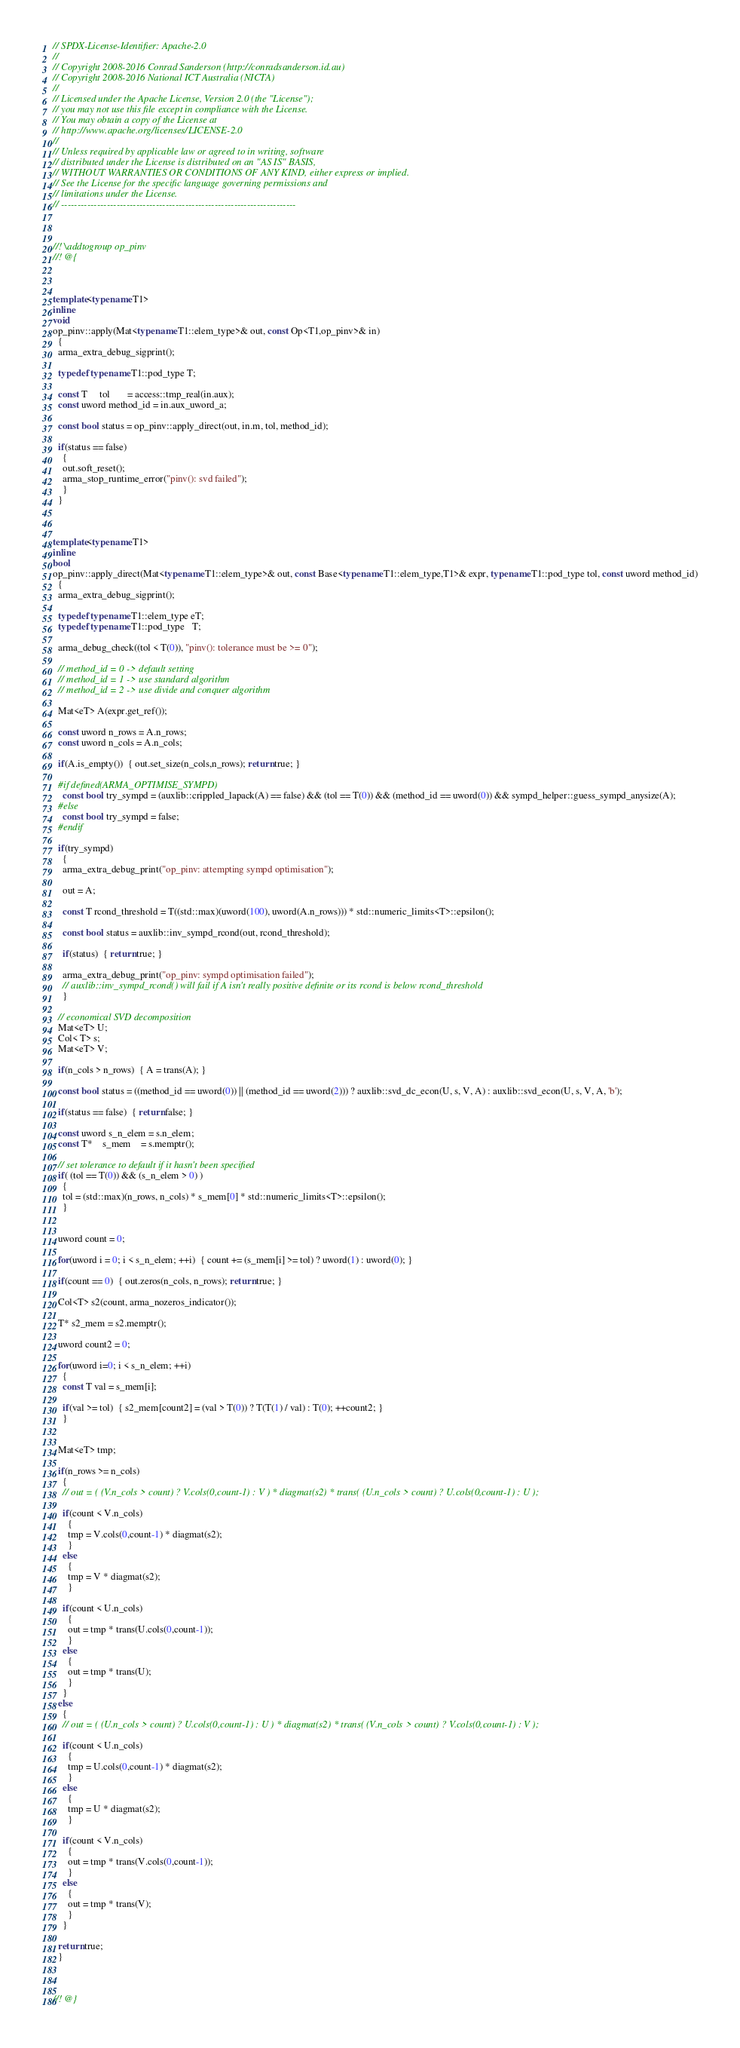<code> <loc_0><loc_0><loc_500><loc_500><_C++_>// SPDX-License-Identifier: Apache-2.0
// 
// Copyright 2008-2016 Conrad Sanderson (http://conradsanderson.id.au)
// Copyright 2008-2016 National ICT Australia (NICTA)
// 
// Licensed under the Apache License, Version 2.0 (the "License");
// you may not use this file except in compliance with the License.
// You may obtain a copy of the License at
// http://www.apache.org/licenses/LICENSE-2.0
// 
// Unless required by applicable law or agreed to in writing, software
// distributed under the License is distributed on an "AS IS" BASIS,
// WITHOUT WARRANTIES OR CONDITIONS OF ANY KIND, either express or implied.
// See the License for the specific language governing permissions and
// limitations under the License.
// ------------------------------------------------------------------------



//! \addtogroup op_pinv
//! @{



template<typename T1>
inline
void
op_pinv::apply(Mat<typename T1::elem_type>& out, const Op<T1,op_pinv>& in)
  {
  arma_extra_debug_sigprint();
  
  typedef typename T1::pod_type T;
  
  const T     tol       = access::tmp_real(in.aux);
  const uword method_id = in.aux_uword_a;
  
  const bool status = op_pinv::apply_direct(out, in.m, tol, method_id);
  
  if(status == false)
    {
    out.soft_reset();
    arma_stop_runtime_error("pinv(): svd failed");
    }
  }



template<typename T1>
inline
bool
op_pinv::apply_direct(Mat<typename T1::elem_type>& out, const Base<typename T1::elem_type,T1>& expr, typename T1::pod_type tol, const uword method_id)
  {
  arma_extra_debug_sigprint();
  
  typedef typename T1::elem_type eT;
  typedef typename T1::pod_type   T;
  
  arma_debug_check((tol < T(0)), "pinv(): tolerance must be >= 0");
  
  // method_id = 0 -> default setting
  // method_id = 1 -> use standard algorithm
  // method_id = 2 -> use divide and conquer algorithm
  
  Mat<eT> A(expr.get_ref());
  
  const uword n_rows = A.n_rows;
  const uword n_cols = A.n_cols;
  
  if(A.is_empty())  { out.set_size(n_cols,n_rows); return true; }
  
  #if defined(ARMA_OPTIMISE_SYMPD)
    const bool try_sympd = (auxlib::crippled_lapack(A) == false) && (tol == T(0)) && (method_id == uword(0)) && sympd_helper::guess_sympd_anysize(A);
  #else
    const bool try_sympd = false;
  #endif
  
  if(try_sympd)
    {
    arma_extra_debug_print("op_pinv: attempting sympd optimisation");
    
    out = A;
    
    const T rcond_threshold = T((std::max)(uword(100), uword(A.n_rows))) * std::numeric_limits<T>::epsilon();
    
    const bool status = auxlib::inv_sympd_rcond(out, rcond_threshold);
    
    if(status)  { return true; }
    
    arma_extra_debug_print("op_pinv: sympd optimisation failed");
    // auxlib::inv_sympd_rcond() will fail if A isn't really positive definite or its rcond is below rcond_threshold
    }
  
  // economical SVD decomposition 
  Mat<eT> U;
  Col< T> s;
  Mat<eT> V;
  
  if(n_cols > n_rows)  { A = trans(A); }
  
  const bool status = ((method_id == uword(0)) || (method_id == uword(2))) ? auxlib::svd_dc_econ(U, s, V, A) : auxlib::svd_econ(U, s, V, A, 'b');
  
  if(status == false)  { return false; }
  
  const uword s_n_elem = s.n_elem;
  const T*    s_mem    = s.memptr();
  
  // set tolerance to default if it hasn't been specified
  if( (tol == T(0)) && (s_n_elem > 0) )
    {
    tol = (std::max)(n_rows, n_cols) * s_mem[0] * std::numeric_limits<T>::epsilon();
    }
  
  
  uword count = 0;
  
  for(uword i = 0; i < s_n_elem; ++i)  { count += (s_mem[i] >= tol) ? uword(1) : uword(0); }
  
  if(count == 0)  { out.zeros(n_cols, n_rows); return true; }
  
  Col<T> s2(count, arma_nozeros_indicator());
  
  T* s2_mem = s2.memptr();
  
  uword count2 = 0;
  
  for(uword i=0; i < s_n_elem; ++i)
    {
    const T val = s_mem[i];
    
    if(val >= tol)  { s2_mem[count2] = (val > T(0)) ? T(T(1) / val) : T(0); ++count2; }
    }
  
  
  Mat<eT> tmp;
    
  if(n_rows >= n_cols)
    {
    // out = ( (V.n_cols > count) ? V.cols(0,count-1) : V ) * diagmat(s2) * trans( (U.n_cols > count) ? U.cols(0,count-1) : U );
    
    if(count < V.n_cols)
      {
      tmp = V.cols(0,count-1) * diagmat(s2);
      }
    else
      {
      tmp = V * diagmat(s2);
      }
    
    if(count < U.n_cols)
      {
      out = tmp * trans(U.cols(0,count-1));
      }
    else
      {
      out = tmp * trans(U);
      }
    }
  else
    {
    // out = ( (U.n_cols > count) ? U.cols(0,count-1) : U ) * diagmat(s2) * trans( (V.n_cols > count) ? V.cols(0,count-1) : V );
    
    if(count < U.n_cols)
      {
      tmp = U.cols(0,count-1) * diagmat(s2);
      }
    else
      {
      tmp = U * diagmat(s2);
      }
    
    if(count < V.n_cols)
      {
      out = tmp * trans(V.cols(0,count-1));
      }
    else
      {
      out = tmp * trans(V);
      }
    }
  
  return true;
  }



//! @}
</code> 